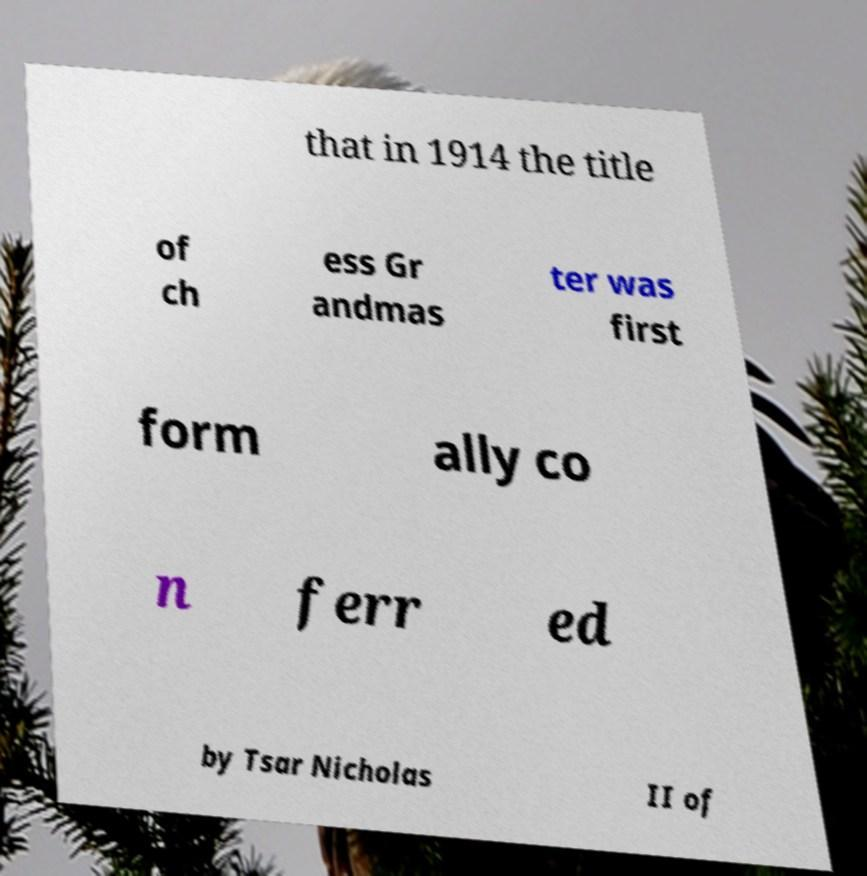There's text embedded in this image that I need extracted. Can you transcribe it verbatim? that in 1914 the title of ch ess Gr andmas ter was first form ally co n ferr ed by Tsar Nicholas II of 